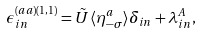<formula> <loc_0><loc_0><loc_500><loc_500>\epsilon ^ { ( a a ) ( 1 , 1 ) } _ { i n } = \tilde { U } \langle \eta _ { - \sigma } ^ { a } \rangle \delta _ { i n } + \lambda _ { i n } ^ { A } ,</formula> 